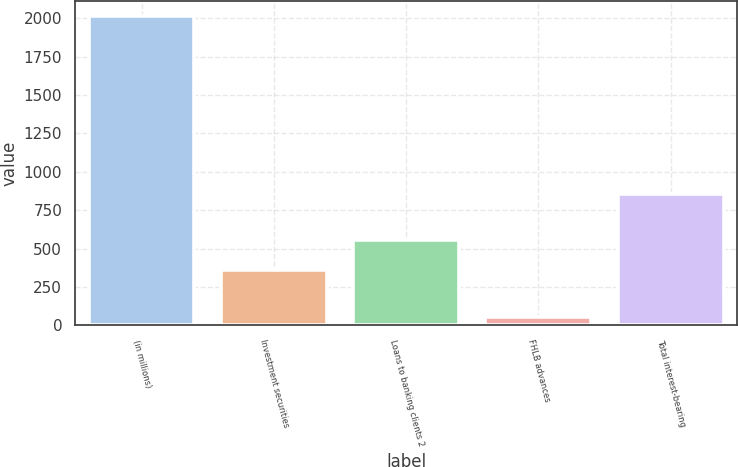Convert chart. <chart><loc_0><loc_0><loc_500><loc_500><bar_chart><fcel>(in millions)<fcel>Investment securities<fcel>Loans to banking clients 2<fcel>FHLB advances<fcel>Total interest-bearing<nl><fcel>2011<fcel>359.1<fcel>554.85<fcel>53.5<fcel>855.4<nl></chart> 